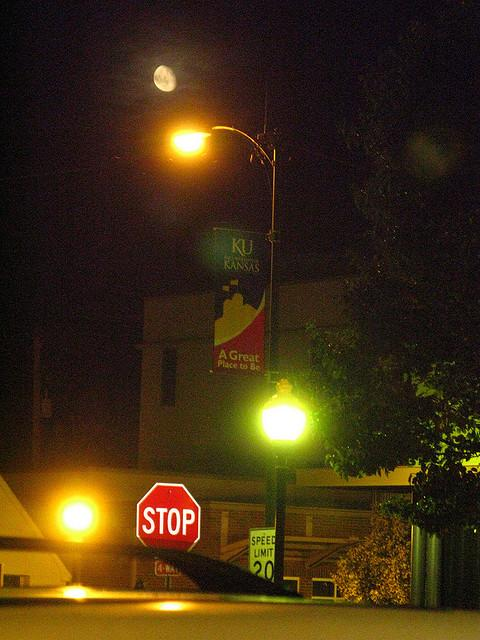How many lights are shining bright on the side of the campus street?

Choices:
A) six
B) one
C) two
D) three three 